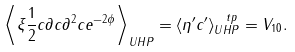Convert formula to latex. <formula><loc_0><loc_0><loc_500><loc_500>\left \langle \xi \frac { 1 } { 2 } c \partial c \partial ^ { 2 } c e ^ { - 2 \phi } \right \rangle _ { U H P } = \langle \eta ^ { \prime } c ^ { \prime } \rangle ^ { \ t p } _ { U H P } = V _ { 1 0 } .</formula> 